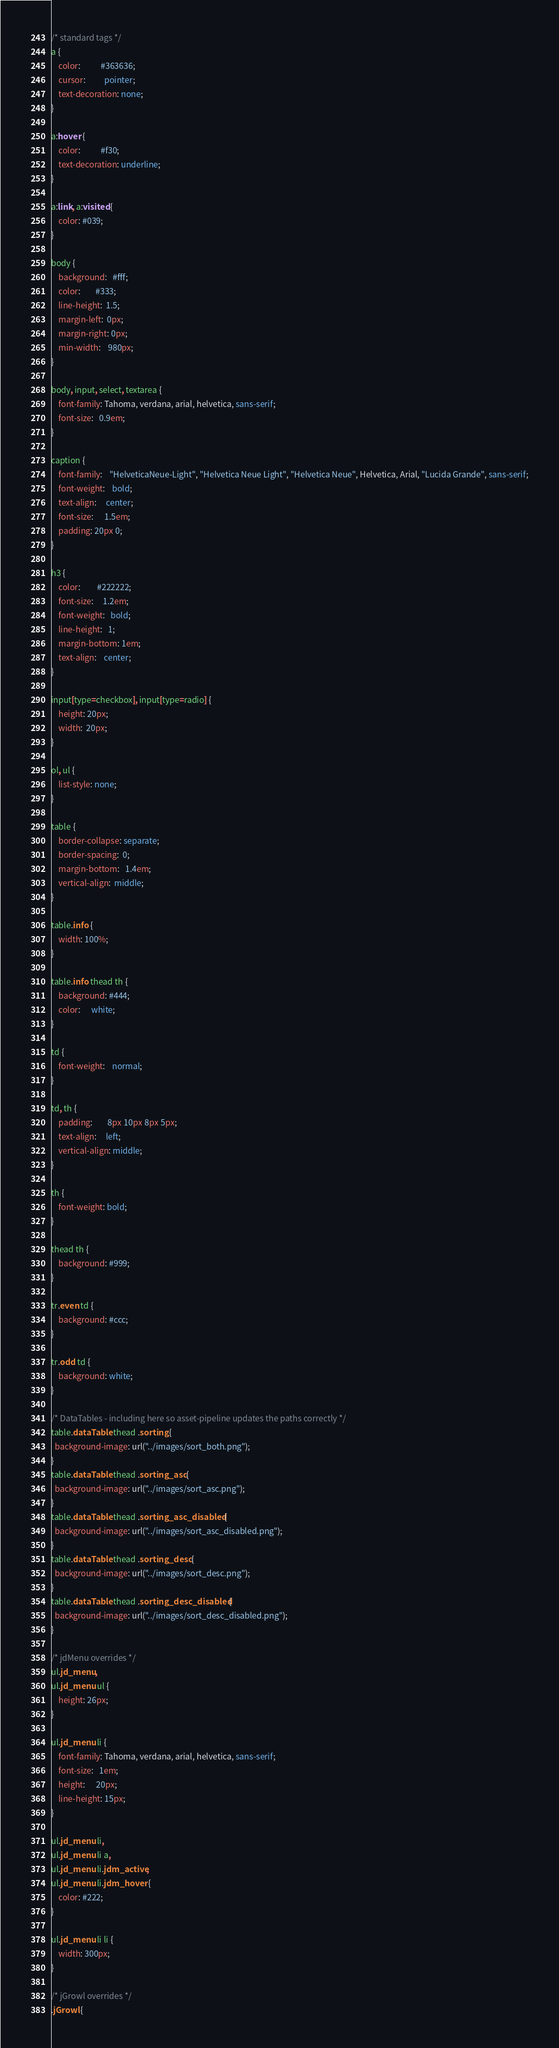<code> <loc_0><loc_0><loc_500><loc_500><_CSS_>/* standard tags */
a {
	color:           #363636;
	cursor:          pointer;
	text-decoration: none;
}

a:hover {
	color:           #f30;
	text-decoration: underline;
}

a:link, a:visited {
	color: #039;
}

body {
	background:   #fff;
	color:        #333;
	line-height:  1.5;
	margin-left:  0px;
	margin-right: 0px;
	min-width:    980px;
}

body, input, select, textarea {
	font-family: Tahoma, verdana, arial, helvetica, sans-serif;
	font-size:   0.9em;
}

caption {
	font-family:    "HelveticaNeue-Light", "Helvetica Neue Light", "Helvetica Neue", Helvetica, Arial, "Lucida Grande", sans-serif;
	font-weight:    bold;
	text-align:     center;
	font-size:      1.5em;
	padding: 20px 0;
}

h3 {
	color:         #222222;
	font-size:     1.2em;
	font-weight:   bold;
	line-height:   1;
	margin-bottom: 1em;
	text-align:    center;
}

input[type=checkbox], input[type=radio] {
	height: 20px;
	width:  20px;
}

ol, ul {
	list-style: none;
}

table {
	border-collapse: separate;
	border-spacing:  0;
	margin-bottom:   1.4em;
	vertical-align:  middle;
}

table.info {
	width: 100%;
}

table.info thead th {
	background: #444;
	color:      white;
}

td {
	font-weight:    normal;
}

td, th {
	padding:        8px 10px 8px 5px;
	text-align:     left;
	vertical-align: middle;
}

th {
	font-weight: bold;
}

thead th {
	background: #999;
}

tr.even td {
	background: #ccc;
}

tr.odd td {
	background: white;
}

/* DataTables - including here so asset-pipeline updates the paths correctly */
table.dataTable thead .sorting {
  background-image: url("../images/sort_both.png");
}
table.dataTable thead .sorting_asc {
  background-image: url("../images/sort_asc.png");
}
table.dataTable thead .sorting_asc_disabled {
  background-image: url("../images/sort_asc_disabled.png");
}
table.dataTable thead .sorting_desc {
  background-image: url("../images/sort_desc.png");
}
table.dataTable thead .sorting_desc_disabled {
  background-image: url("../images/sort_desc_disabled.png");
}

/* jdMenu overrides */
ul.jd_menu,
ul.jd_menu ul {
	height: 26px;
}

ul.jd_menu li {
	font-family: Tahoma, verdana, arial, helvetica, sans-serif;
	font-size:   1em;
	height:      20px;
	line-height: 15px;
}

ul.jd_menu li,
ul.jd_menu li a,
ul.jd_menu li.jdm_active,
ul.jd_menu li.jdm_hover {
	color: #222;
}

ul.jd_menu li li {
	width: 300px;
}

/* jGrowl overrides */
.jGrowl {</code> 